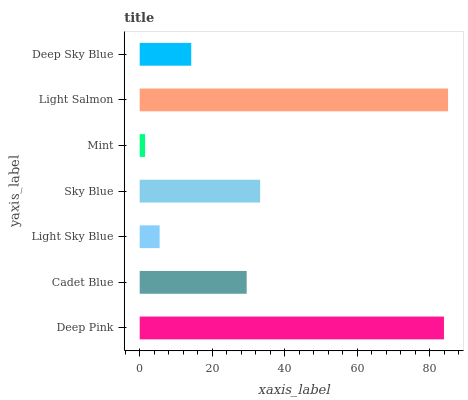Is Mint the minimum?
Answer yes or no. Yes. Is Light Salmon the maximum?
Answer yes or no. Yes. Is Cadet Blue the minimum?
Answer yes or no. No. Is Cadet Blue the maximum?
Answer yes or no. No. Is Deep Pink greater than Cadet Blue?
Answer yes or no. Yes. Is Cadet Blue less than Deep Pink?
Answer yes or no. Yes. Is Cadet Blue greater than Deep Pink?
Answer yes or no. No. Is Deep Pink less than Cadet Blue?
Answer yes or no. No. Is Cadet Blue the high median?
Answer yes or no. Yes. Is Cadet Blue the low median?
Answer yes or no. Yes. Is Mint the high median?
Answer yes or no. No. Is Light Sky Blue the low median?
Answer yes or no. No. 